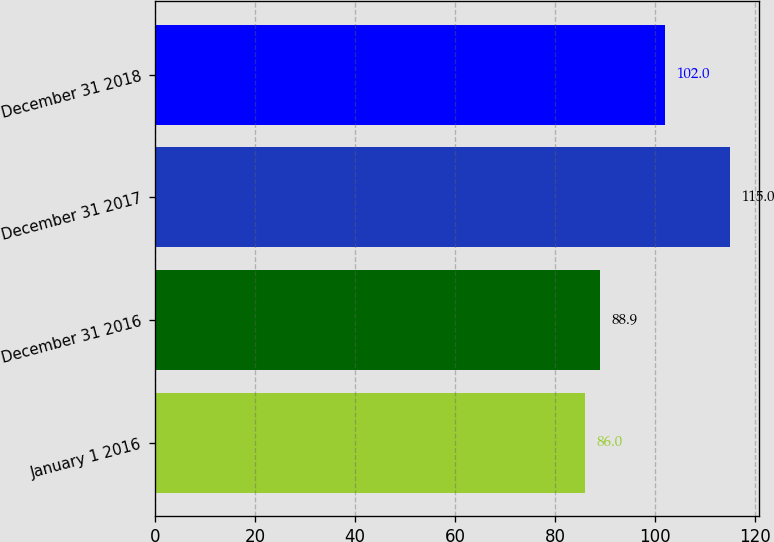<chart> <loc_0><loc_0><loc_500><loc_500><bar_chart><fcel>January 1 2016<fcel>December 31 2016<fcel>December 31 2017<fcel>December 31 2018<nl><fcel>86<fcel>88.9<fcel>115<fcel>102<nl></chart> 